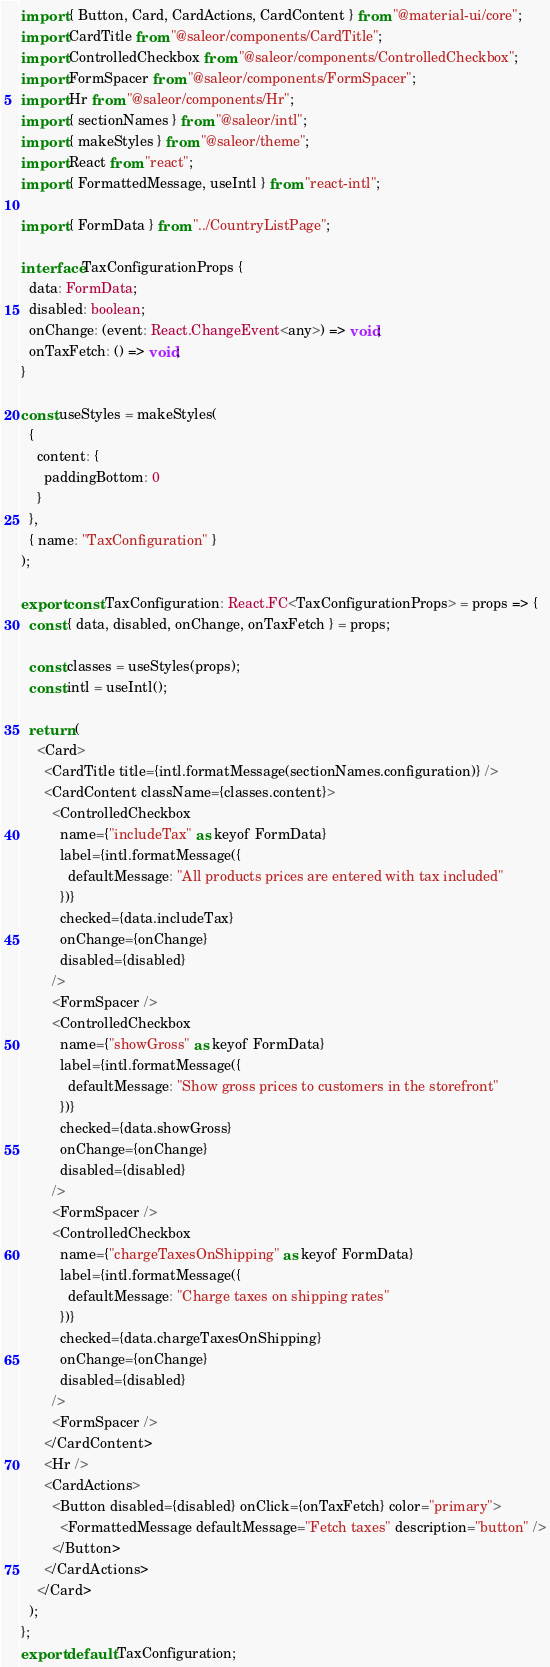Convert code to text. <code><loc_0><loc_0><loc_500><loc_500><_TypeScript_>import { Button, Card, CardActions, CardContent } from "@material-ui/core";
import CardTitle from "@saleor/components/CardTitle";
import ControlledCheckbox from "@saleor/components/ControlledCheckbox";
import FormSpacer from "@saleor/components/FormSpacer";
import Hr from "@saleor/components/Hr";
import { sectionNames } from "@saleor/intl";
import { makeStyles } from "@saleor/theme";
import React from "react";
import { FormattedMessage, useIntl } from "react-intl";

import { FormData } from "../CountryListPage";

interface TaxConfigurationProps {
  data: FormData;
  disabled: boolean;
  onChange: (event: React.ChangeEvent<any>) => void;
  onTaxFetch: () => void;
}

const useStyles = makeStyles(
  {
    content: {
      paddingBottom: 0
    }
  },
  { name: "TaxConfiguration" }
);

export const TaxConfiguration: React.FC<TaxConfigurationProps> = props => {
  const { data, disabled, onChange, onTaxFetch } = props;

  const classes = useStyles(props);
  const intl = useIntl();

  return (
    <Card>
      <CardTitle title={intl.formatMessage(sectionNames.configuration)} />
      <CardContent className={classes.content}>
        <ControlledCheckbox
          name={"includeTax" as keyof FormData}
          label={intl.formatMessage({
            defaultMessage: "All products prices are entered with tax included"
          })}
          checked={data.includeTax}
          onChange={onChange}
          disabled={disabled}
        />
        <FormSpacer />
        <ControlledCheckbox
          name={"showGross" as keyof FormData}
          label={intl.formatMessage({
            defaultMessage: "Show gross prices to customers in the storefront"
          })}
          checked={data.showGross}
          onChange={onChange}
          disabled={disabled}
        />
        <FormSpacer />
        <ControlledCheckbox
          name={"chargeTaxesOnShipping" as keyof FormData}
          label={intl.formatMessage({
            defaultMessage: "Charge taxes on shipping rates"
          })}
          checked={data.chargeTaxesOnShipping}
          onChange={onChange}
          disabled={disabled}
        />
        <FormSpacer />
      </CardContent>
      <Hr />
      <CardActions>
        <Button disabled={disabled} onClick={onTaxFetch} color="primary">
          <FormattedMessage defaultMessage="Fetch taxes" description="button" />
        </Button>
      </CardActions>
    </Card>
  );
};
export default TaxConfiguration;
</code> 